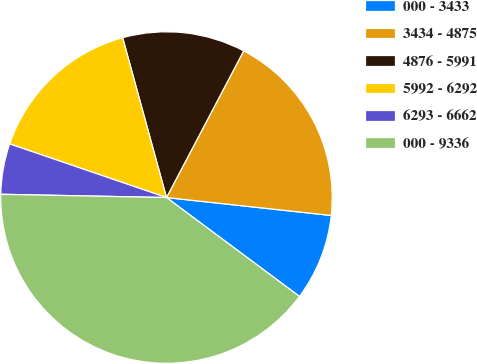<chart> <loc_0><loc_0><loc_500><loc_500><pie_chart><fcel>000 - 3433<fcel>3434 - 4875<fcel>4876 - 5991<fcel>5992 - 6292<fcel>6293 - 6662<fcel>000 - 9336<nl><fcel>8.45%<fcel>19.01%<fcel>11.97%<fcel>15.49%<fcel>4.93%<fcel>40.13%<nl></chart> 